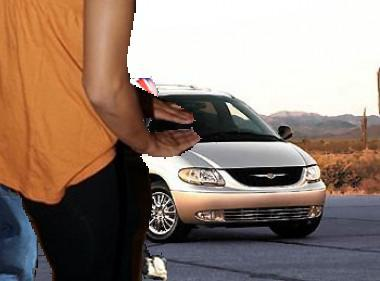How many unicorns would there be in the image after one more unicorn has been added in the image? If the current image had a unicorn and you were to add one more, there would be two unicorns in total. 